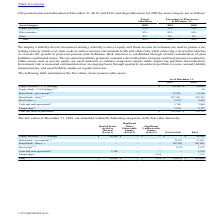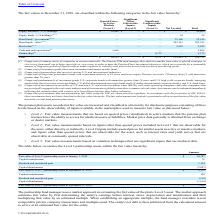From Cts Corporation's financial document, Which years does the table provide information for the fair values of the company's pension plan assets? The document shows two values: 2019 and 2018. From the document: "Asset Category 2020 2019 2018 Asset Category 2020 2019 2018..." Also, What were the Equity securities - U.S. holdings in 2018? According to the financial document, 20,469 (in thousands). The relevant text states: "Equity securities - U.S. holdings (1) $ 24,586 $ 20,469..." Also, What was the amount of Other bond funds in 2019? According to the financial document, 207,901 (in thousands). The relevant text states: "Bond funds - other (5) (7) 207,901 202,393..." Also, can you calculate: What was the change in Real Estate between 2018 and 2019? Based on the calculation: 2,979-2,652, the result is 327 (in thousands). This is based on the information: "Real estate (6) (7) 2,979 2,652 Real estate (6) (7) 2,979 2,652..." The key data points involved are: 2,652, 2,979. Also, can you calculate: What was the change in the government bond funds between 2018 and 2019? Based on the calculation: 33,991-19,146, the result is 14845 (in thousands). This is based on the information: "Bond funds - government (4) (7) 33,991 19,146 Bond funds - government (4) (7) 33,991 19,146..." The key data points involved are: 19,146, 33,991. Also, can you calculate: What was the percentage change in Partnerships between 2018 and 2019? To answer this question, I need to perform calculations using the financial data. The calculation is: (7,539-9,172)/9,172, which equals -17.8 (percentage). This is based on the information: "Partnerships (3) 7,539 9,172 Partnerships (3) 7,539 9,172..." The key data points involved are: 7,539, 9,172. 